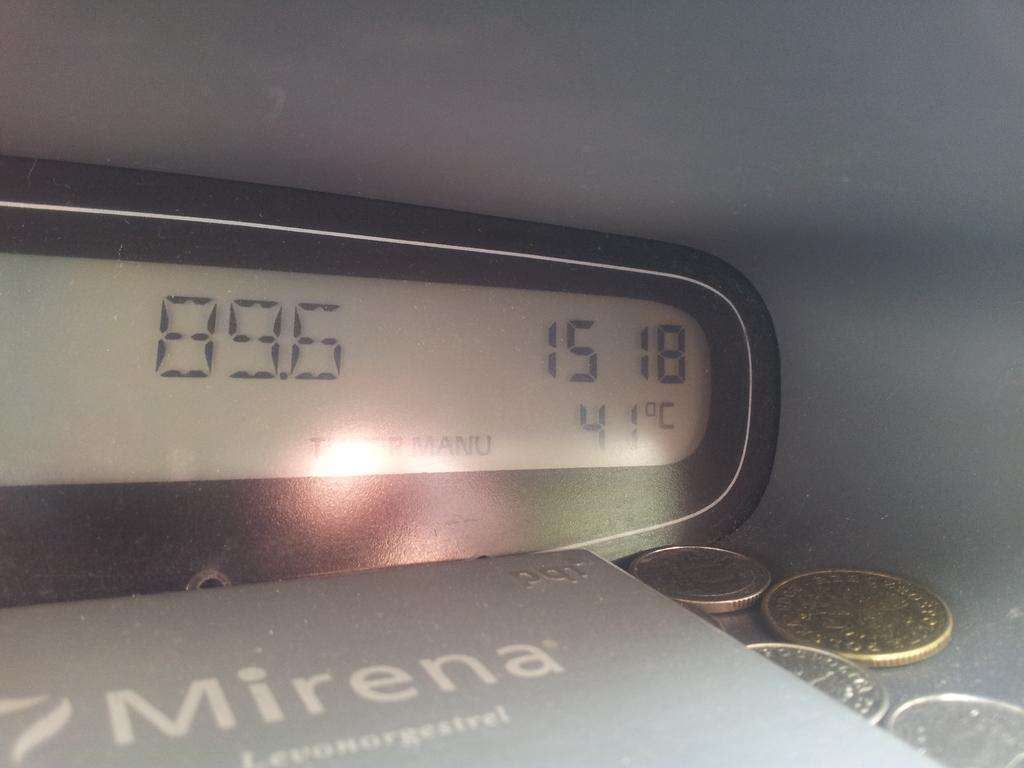Provide a one-sentence caption for the provided image. A Book titled Mirena with a digital watch and some coins on the table. 